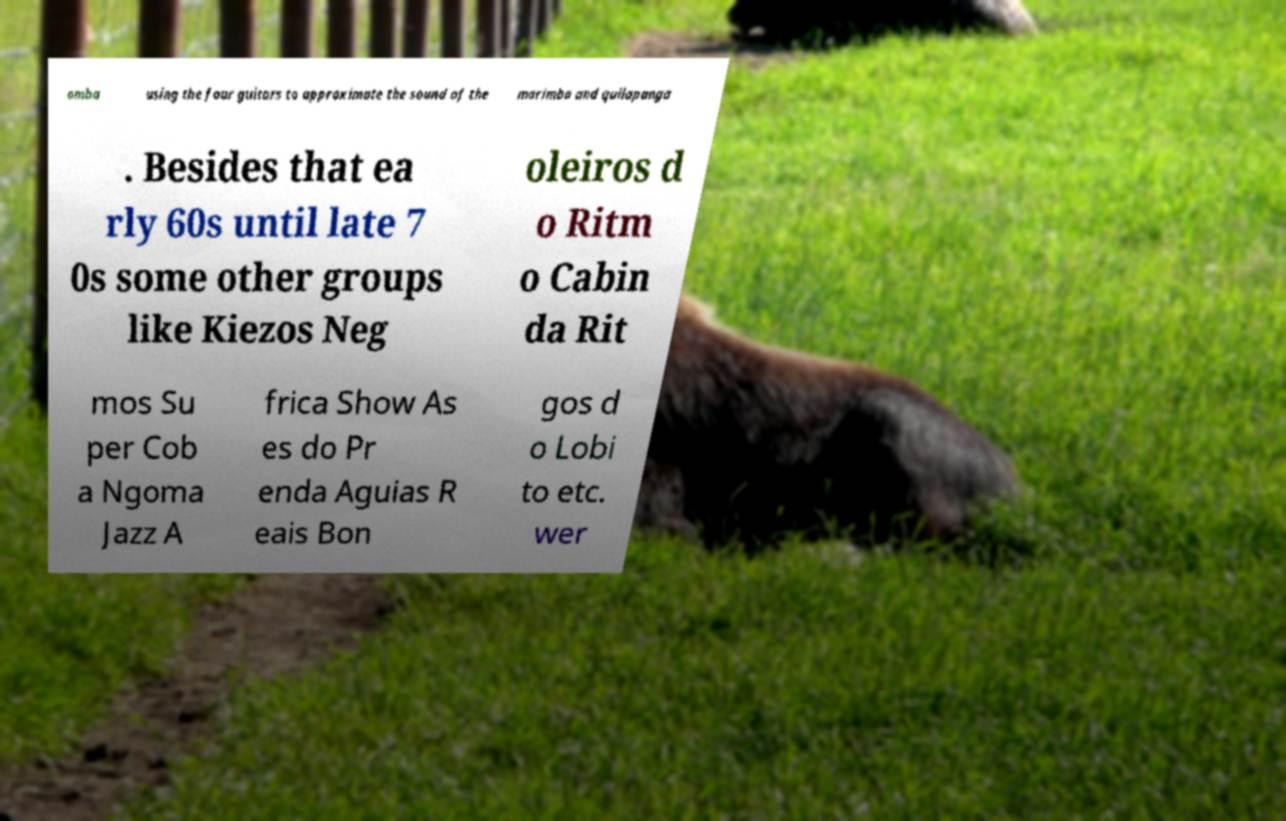What messages or text are displayed in this image? I need them in a readable, typed format. omba using the four guitars to approximate the sound of the marimba and quilapanga . Besides that ea rly 60s until late 7 0s some other groups like Kiezos Neg oleiros d o Ritm o Cabin da Rit mos Su per Cob a Ngoma Jazz A frica Show As es do Pr enda Aguias R eais Bon gos d o Lobi to etc. wer 